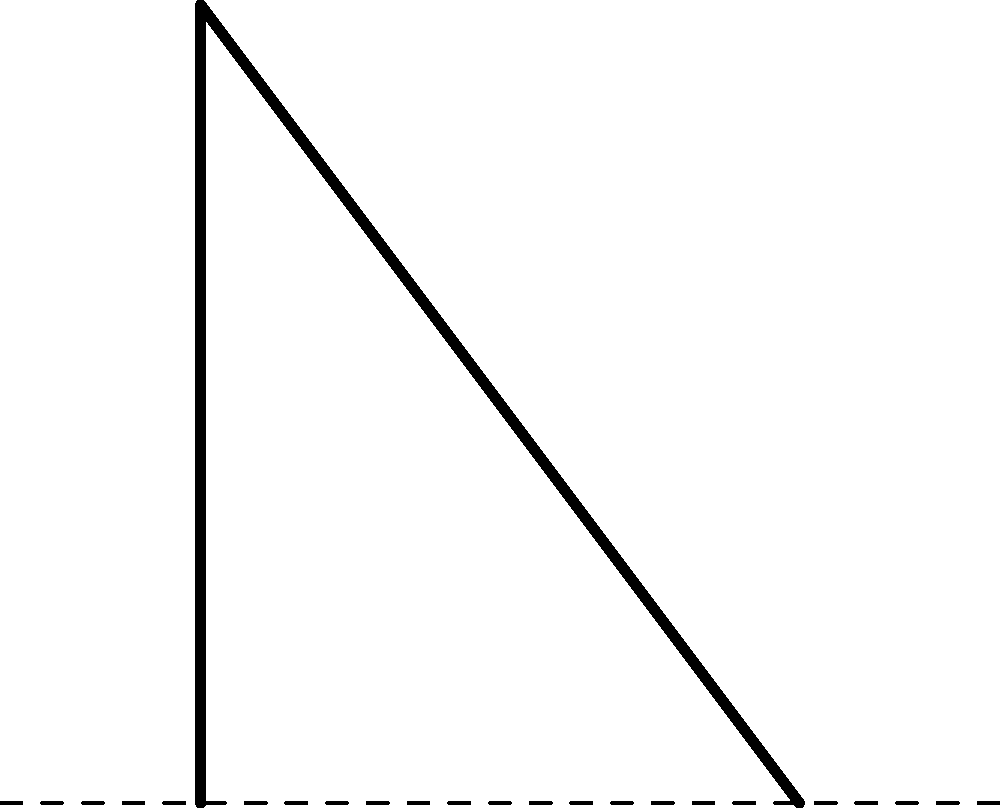During a squat exercise, a force $F$ of 1000 N is applied vertically on the lower leg at a distance $d$ of 0.3 m from the knee joint. If the angle $\theta$ between the lower leg and the ground is 60°, calculate the magnitude of the torque acting on the knee joint. To solve this problem, we'll follow these steps:

1) The torque $\tau$ is given by the formula:
   $$\tau = F \cdot r \cdot \sin(\alpha)$$
   where $F$ is the applied force, $r$ is the distance from the axis of rotation to the point of force application, and $\alpha$ is the angle between the force vector and the radius vector.

2) We're given:
   - $F = 1000$ N
   - $d = 0.3$ m
   - $\theta = 60°$

3) In this case, $r = d = 0.3$ m, and $\alpha = 90° - \theta = 30°$ (because the force is perpendicular to the ground, while we need the angle to the leg).

4) Substituting these values into the torque equation:
   $$\tau = 1000 \text{ N} \cdot 0.3 \text{ m} \cdot \sin(30°)$$

5) Calculate $\sin(30°)$:
   $$\sin(30°) = 0.5$$

6) Now we can compute the torque:
   $$\tau = 1000 \cdot 0.3 \cdot 0.5 = 150 \text{ N⋅m}$$

Therefore, the magnitude of the torque acting on the knee joint is 150 N⋅m.
Answer: 150 N⋅m 